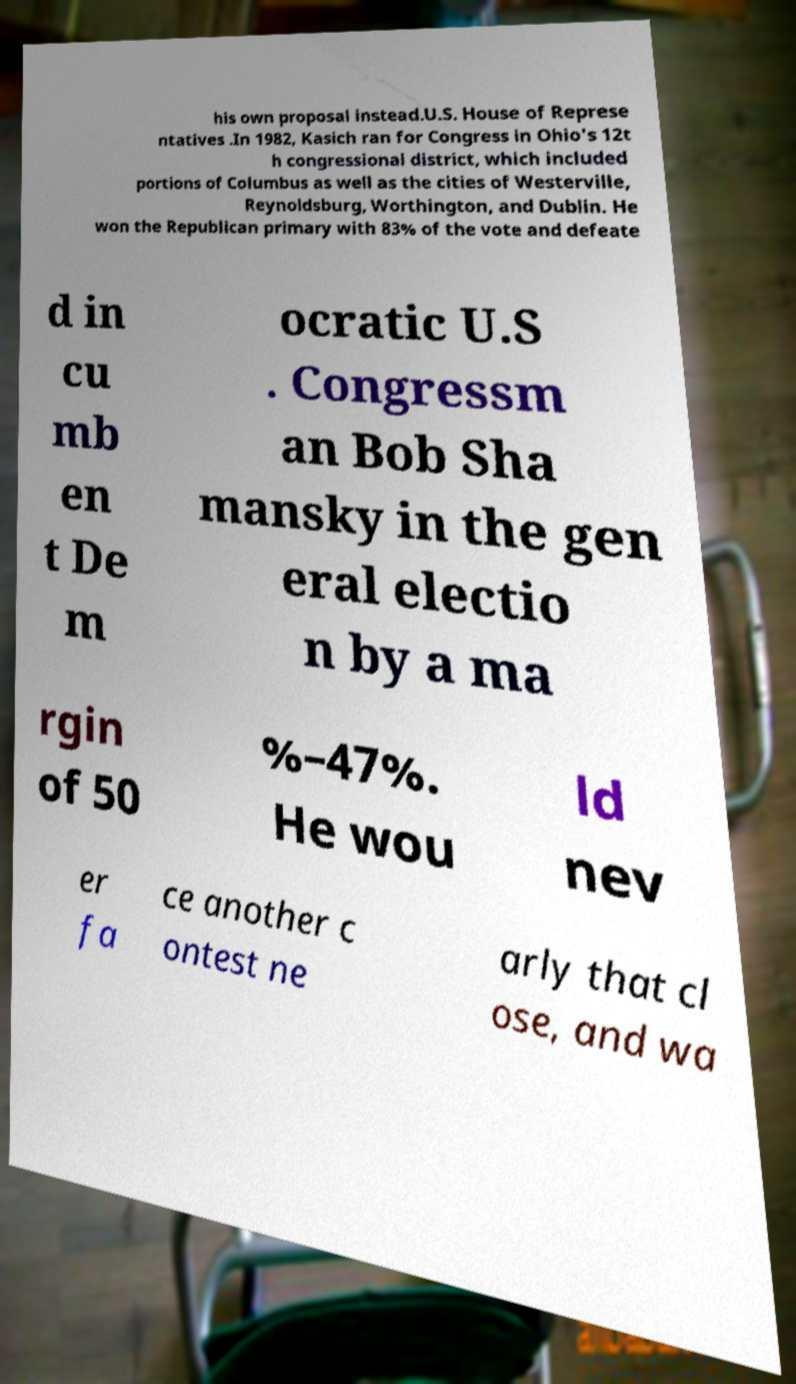Please identify and transcribe the text found in this image. his own proposal instead.U.S. House of Represe ntatives .In 1982, Kasich ran for Congress in Ohio's 12t h congressional district, which included portions of Columbus as well as the cities of Westerville, Reynoldsburg, Worthington, and Dublin. He won the Republican primary with 83% of the vote and defeate d in cu mb en t De m ocratic U.S . Congressm an Bob Sha mansky in the gen eral electio n by a ma rgin of 50 %–47%. He wou ld nev er fa ce another c ontest ne arly that cl ose, and wa 